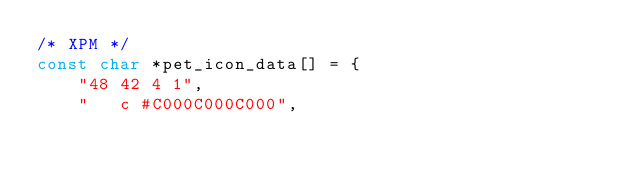<code> <loc_0><loc_0><loc_500><loc_500><_C_>/* XPM */
const char *pet_icon_data[] = {
    "48 42 4 1",
    " 	c #C000C000C000",</code> 